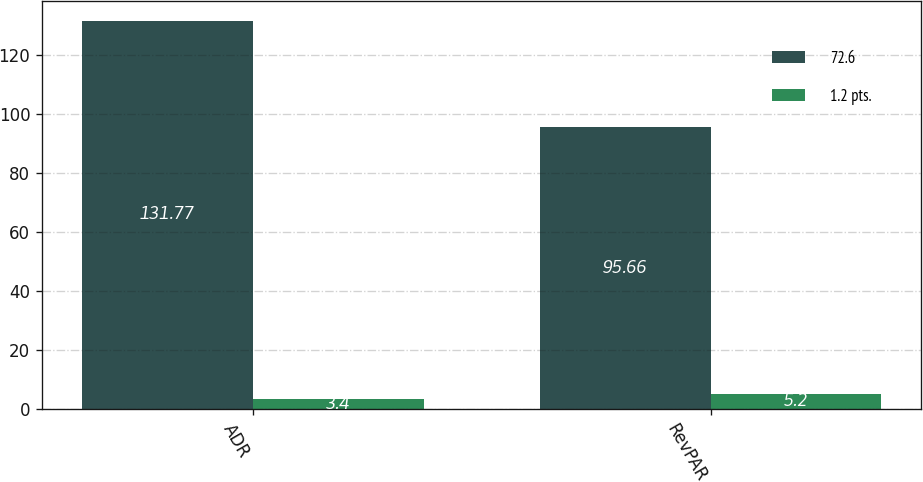Convert chart to OTSL. <chart><loc_0><loc_0><loc_500><loc_500><stacked_bar_chart><ecel><fcel>ADR<fcel>RevPAR<nl><fcel>72.6<fcel>131.77<fcel>95.66<nl><fcel>1.2 pts.<fcel>3.4<fcel>5.2<nl></chart> 